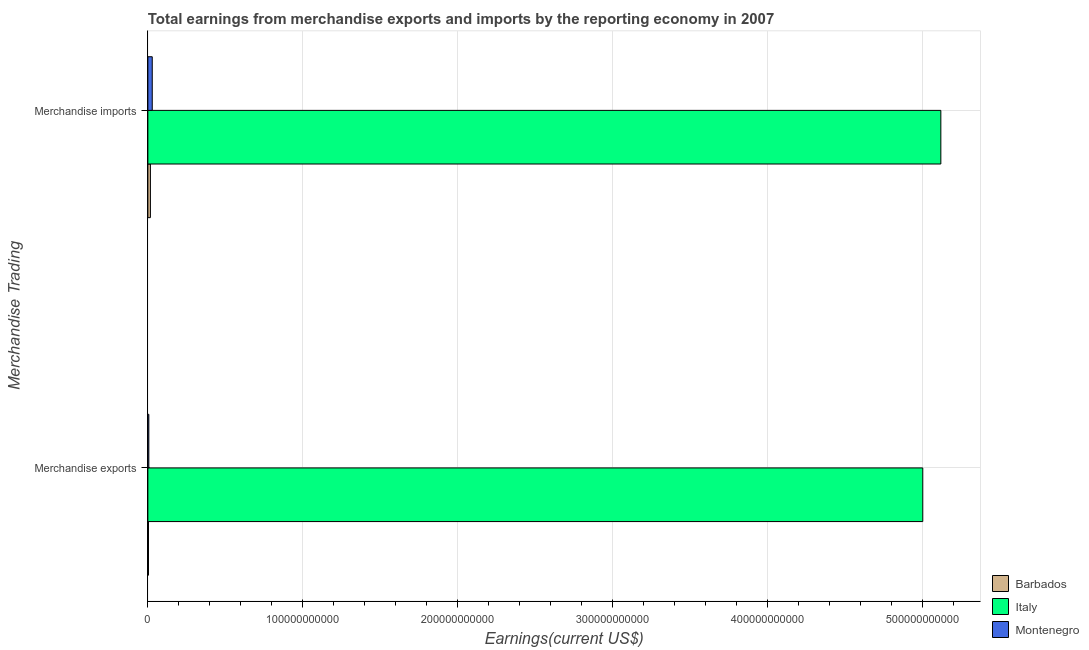Are the number of bars on each tick of the Y-axis equal?
Your answer should be very brief. Yes. What is the earnings from merchandise exports in Barbados?
Offer a terse response. 4.02e+08. Across all countries, what is the maximum earnings from merchandise exports?
Provide a short and direct response. 5.00e+11. Across all countries, what is the minimum earnings from merchandise imports?
Provide a succinct answer. 1.64e+09. In which country was the earnings from merchandise exports minimum?
Keep it short and to the point. Barbados. What is the total earnings from merchandise imports in the graph?
Provide a succinct answer. 5.16e+11. What is the difference between the earnings from merchandise exports in Barbados and that in Italy?
Your answer should be compact. -5.00e+11. What is the difference between the earnings from merchandise imports in Barbados and the earnings from merchandise exports in Montenegro?
Keep it short and to the point. 1.02e+09. What is the average earnings from merchandise exports per country?
Your response must be concise. 1.67e+11. What is the difference between the earnings from merchandise exports and earnings from merchandise imports in Barbados?
Your answer should be very brief. -1.24e+09. In how many countries, is the earnings from merchandise exports greater than 480000000000 US$?
Keep it short and to the point. 1. What is the ratio of the earnings from merchandise exports in Montenegro to that in Italy?
Give a very brief answer. 0. Is the earnings from merchandise imports in Montenegro less than that in Italy?
Your answer should be compact. Yes. What does the 3rd bar from the top in Merchandise imports represents?
Your answer should be very brief. Barbados. What does the 2nd bar from the bottom in Merchandise exports represents?
Your answer should be very brief. Italy. How many countries are there in the graph?
Keep it short and to the point. 3. What is the difference between two consecutive major ticks on the X-axis?
Offer a terse response. 1.00e+11. Does the graph contain any zero values?
Offer a terse response. No. How are the legend labels stacked?
Keep it short and to the point. Vertical. What is the title of the graph?
Provide a short and direct response. Total earnings from merchandise exports and imports by the reporting economy in 2007. What is the label or title of the X-axis?
Keep it short and to the point. Earnings(current US$). What is the label or title of the Y-axis?
Your response must be concise. Merchandise Trading. What is the Earnings(current US$) in Barbados in Merchandise exports?
Offer a very short reply. 4.02e+08. What is the Earnings(current US$) of Italy in Merchandise exports?
Offer a terse response. 5.00e+11. What is the Earnings(current US$) of Montenegro in Merchandise exports?
Your response must be concise. 6.20e+08. What is the Earnings(current US$) in Barbados in Merchandise imports?
Give a very brief answer. 1.64e+09. What is the Earnings(current US$) in Italy in Merchandise imports?
Offer a terse response. 5.12e+11. What is the Earnings(current US$) of Montenegro in Merchandise imports?
Give a very brief answer. 2.83e+09. Across all Merchandise Trading, what is the maximum Earnings(current US$) of Barbados?
Your answer should be very brief. 1.64e+09. Across all Merchandise Trading, what is the maximum Earnings(current US$) in Italy?
Keep it short and to the point. 5.12e+11. Across all Merchandise Trading, what is the maximum Earnings(current US$) in Montenegro?
Offer a terse response. 2.83e+09. Across all Merchandise Trading, what is the minimum Earnings(current US$) in Barbados?
Your answer should be very brief. 4.02e+08. Across all Merchandise Trading, what is the minimum Earnings(current US$) of Italy?
Give a very brief answer. 5.00e+11. Across all Merchandise Trading, what is the minimum Earnings(current US$) in Montenegro?
Give a very brief answer. 6.20e+08. What is the total Earnings(current US$) in Barbados in the graph?
Your answer should be compact. 2.04e+09. What is the total Earnings(current US$) of Italy in the graph?
Make the answer very short. 1.01e+12. What is the total Earnings(current US$) of Montenegro in the graph?
Offer a very short reply. 3.45e+09. What is the difference between the Earnings(current US$) in Barbados in Merchandise exports and that in Merchandise imports?
Offer a terse response. -1.24e+09. What is the difference between the Earnings(current US$) of Italy in Merchandise exports and that in Merchandise imports?
Offer a very short reply. -1.17e+1. What is the difference between the Earnings(current US$) in Montenegro in Merchandise exports and that in Merchandise imports?
Your answer should be very brief. -2.21e+09. What is the difference between the Earnings(current US$) in Barbados in Merchandise exports and the Earnings(current US$) in Italy in Merchandise imports?
Provide a short and direct response. -5.11e+11. What is the difference between the Earnings(current US$) of Barbados in Merchandise exports and the Earnings(current US$) of Montenegro in Merchandise imports?
Offer a very short reply. -2.43e+09. What is the difference between the Earnings(current US$) of Italy in Merchandise exports and the Earnings(current US$) of Montenegro in Merchandise imports?
Make the answer very short. 4.97e+11. What is the average Earnings(current US$) of Barbados per Merchandise Trading?
Ensure brevity in your answer.  1.02e+09. What is the average Earnings(current US$) in Italy per Merchandise Trading?
Offer a very short reply. 5.06e+11. What is the average Earnings(current US$) in Montenegro per Merchandise Trading?
Ensure brevity in your answer.  1.73e+09. What is the difference between the Earnings(current US$) in Barbados and Earnings(current US$) in Italy in Merchandise exports?
Your answer should be compact. -5.00e+11. What is the difference between the Earnings(current US$) in Barbados and Earnings(current US$) in Montenegro in Merchandise exports?
Make the answer very short. -2.18e+08. What is the difference between the Earnings(current US$) in Italy and Earnings(current US$) in Montenegro in Merchandise exports?
Your answer should be very brief. 5.00e+11. What is the difference between the Earnings(current US$) in Barbados and Earnings(current US$) in Italy in Merchandise imports?
Make the answer very short. -5.10e+11. What is the difference between the Earnings(current US$) of Barbados and Earnings(current US$) of Montenegro in Merchandise imports?
Make the answer very short. -1.19e+09. What is the difference between the Earnings(current US$) of Italy and Earnings(current US$) of Montenegro in Merchandise imports?
Offer a terse response. 5.09e+11. What is the ratio of the Earnings(current US$) in Barbados in Merchandise exports to that in Merchandise imports?
Your answer should be very brief. 0.25. What is the ratio of the Earnings(current US$) in Italy in Merchandise exports to that in Merchandise imports?
Give a very brief answer. 0.98. What is the ratio of the Earnings(current US$) of Montenegro in Merchandise exports to that in Merchandise imports?
Ensure brevity in your answer.  0.22. What is the difference between the highest and the second highest Earnings(current US$) in Barbados?
Your answer should be compact. 1.24e+09. What is the difference between the highest and the second highest Earnings(current US$) in Italy?
Your answer should be compact. 1.17e+1. What is the difference between the highest and the second highest Earnings(current US$) of Montenegro?
Provide a succinct answer. 2.21e+09. What is the difference between the highest and the lowest Earnings(current US$) in Barbados?
Your answer should be compact. 1.24e+09. What is the difference between the highest and the lowest Earnings(current US$) of Italy?
Provide a succinct answer. 1.17e+1. What is the difference between the highest and the lowest Earnings(current US$) of Montenegro?
Give a very brief answer. 2.21e+09. 